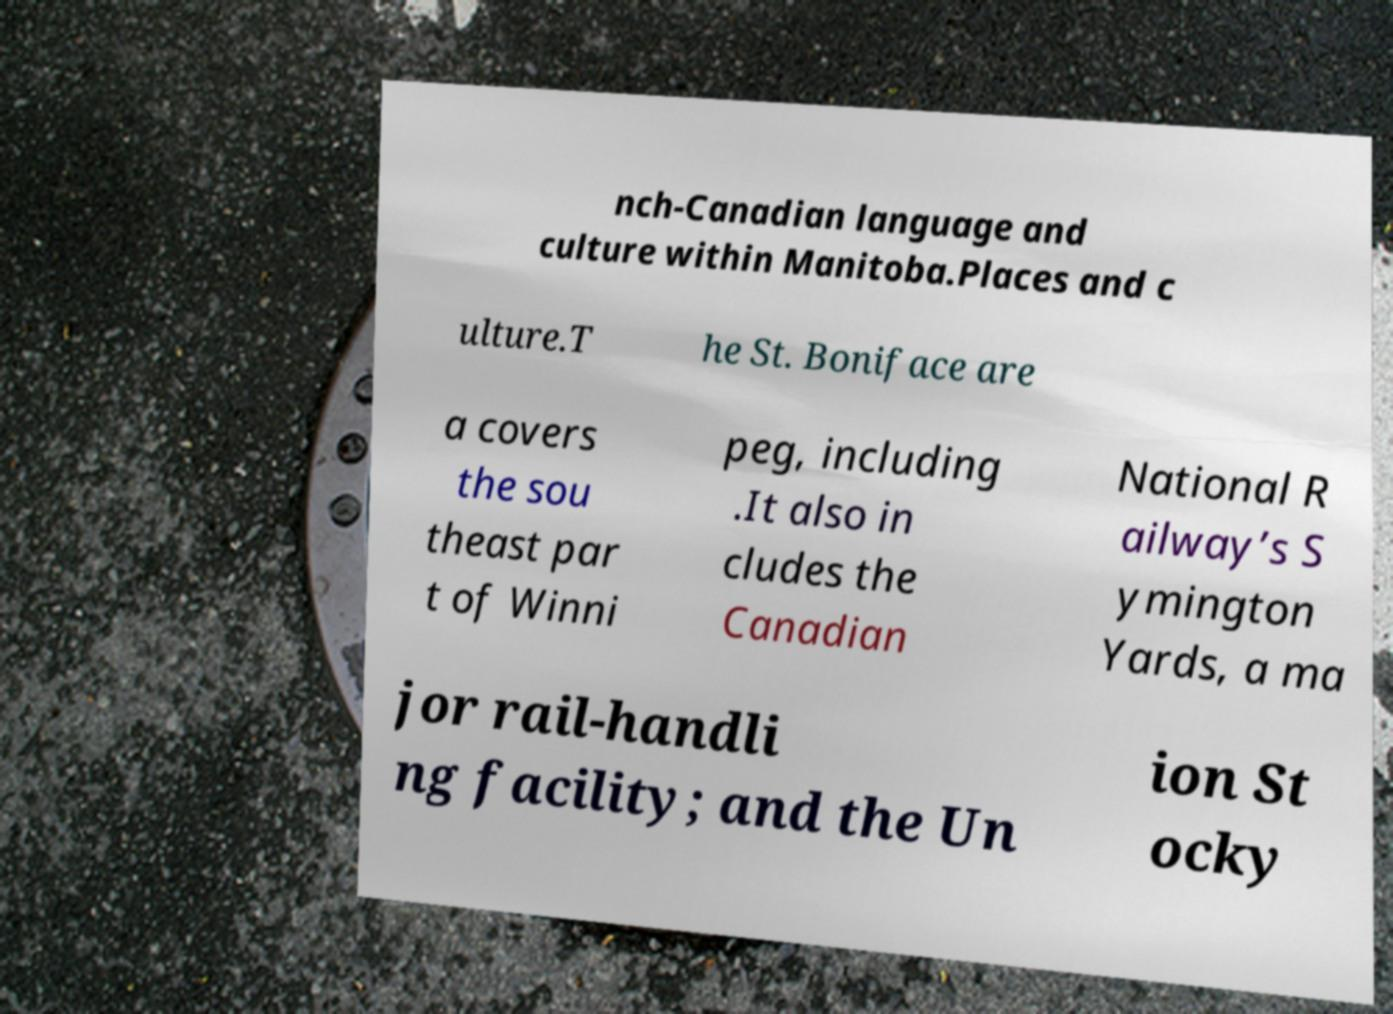What messages or text are displayed in this image? I need them in a readable, typed format. nch-Canadian language and culture within Manitoba.Places and c ulture.T he St. Boniface are a covers the sou theast par t of Winni peg, including .It also in cludes the Canadian National R ailway’s S ymington Yards, a ma jor rail-handli ng facility; and the Un ion St ocky 